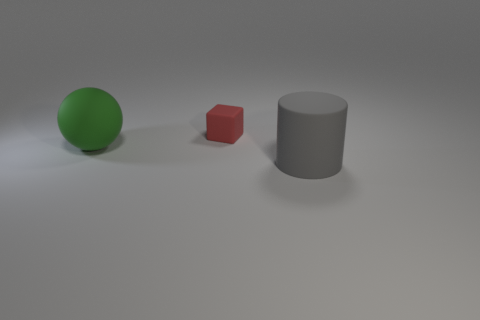Add 2 large gray cylinders. How many objects exist? 5 Subtract all cubes. How many objects are left? 2 Subtract all cyan cubes. Subtract all green cylinders. How many cubes are left? 1 Subtract all big gray rubber things. Subtract all cylinders. How many objects are left? 1 Add 2 large rubber objects. How many large rubber objects are left? 4 Add 3 red rubber blocks. How many red rubber blocks exist? 4 Subtract 0 red cylinders. How many objects are left? 3 